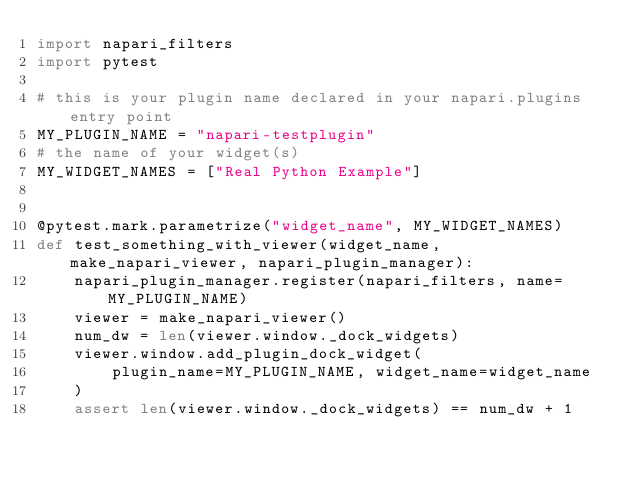Convert code to text. <code><loc_0><loc_0><loc_500><loc_500><_Python_>import napari_filters
import pytest

# this is your plugin name declared in your napari.plugins entry point
MY_PLUGIN_NAME = "napari-testplugin"
# the name of your widget(s)
MY_WIDGET_NAMES = ["Real Python Example"]


@pytest.mark.parametrize("widget_name", MY_WIDGET_NAMES)
def test_something_with_viewer(widget_name, make_napari_viewer, napari_plugin_manager):
    napari_plugin_manager.register(napari_filters, name=MY_PLUGIN_NAME)
    viewer = make_napari_viewer()
    num_dw = len(viewer.window._dock_widgets)
    viewer.window.add_plugin_dock_widget(
        plugin_name=MY_PLUGIN_NAME, widget_name=widget_name
    )
    assert len(viewer.window._dock_widgets) == num_dw + 1
</code> 